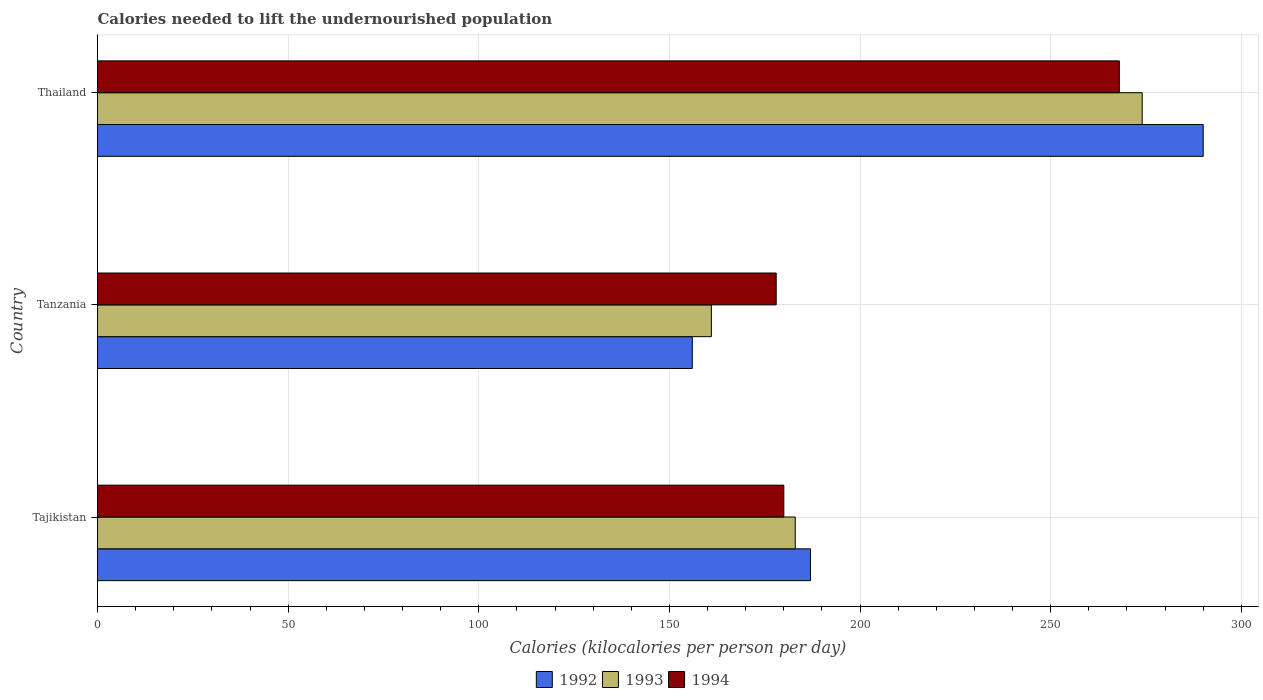How many groups of bars are there?
Provide a short and direct response. 3. Are the number of bars per tick equal to the number of legend labels?
Your response must be concise. Yes. Are the number of bars on each tick of the Y-axis equal?
Your answer should be very brief. Yes. How many bars are there on the 2nd tick from the bottom?
Keep it short and to the point. 3. What is the label of the 2nd group of bars from the top?
Make the answer very short. Tanzania. What is the total calories needed to lift the undernourished population in 1994 in Tajikistan?
Give a very brief answer. 180. Across all countries, what is the maximum total calories needed to lift the undernourished population in 1992?
Offer a very short reply. 290. Across all countries, what is the minimum total calories needed to lift the undernourished population in 1994?
Make the answer very short. 178. In which country was the total calories needed to lift the undernourished population in 1992 maximum?
Keep it short and to the point. Thailand. In which country was the total calories needed to lift the undernourished population in 1994 minimum?
Ensure brevity in your answer.  Tanzania. What is the total total calories needed to lift the undernourished population in 1993 in the graph?
Your answer should be compact. 618. What is the difference between the total calories needed to lift the undernourished population in 1994 in Tajikistan and that in Tanzania?
Your response must be concise. 2. What is the difference between the total calories needed to lift the undernourished population in 1992 in Thailand and the total calories needed to lift the undernourished population in 1994 in Tajikistan?
Keep it short and to the point. 110. What is the average total calories needed to lift the undernourished population in 1994 per country?
Provide a short and direct response. 208.67. What is the difference between the total calories needed to lift the undernourished population in 1992 and total calories needed to lift the undernourished population in 1994 in Thailand?
Your answer should be compact. 22. What is the ratio of the total calories needed to lift the undernourished population in 1992 in Tanzania to that in Thailand?
Your answer should be very brief. 0.54. Is the total calories needed to lift the undernourished population in 1994 in Tanzania less than that in Thailand?
Provide a succinct answer. Yes. What is the difference between the highest and the lowest total calories needed to lift the undernourished population in 1994?
Give a very brief answer. 90. In how many countries, is the total calories needed to lift the undernourished population in 1993 greater than the average total calories needed to lift the undernourished population in 1993 taken over all countries?
Offer a terse response. 1. What does the 3rd bar from the top in Thailand represents?
Your answer should be very brief. 1992. How many bars are there?
Make the answer very short. 9. What is the difference between two consecutive major ticks on the X-axis?
Your answer should be very brief. 50. Does the graph contain grids?
Provide a succinct answer. Yes. Where does the legend appear in the graph?
Make the answer very short. Bottom center. How many legend labels are there?
Ensure brevity in your answer.  3. What is the title of the graph?
Ensure brevity in your answer.  Calories needed to lift the undernourished population. Does "2010" appear as one of the legend labels in the graph?
Keep it short and to the point. No. What is the label or title of the X-axis?
Provide a succinct answer. Calories (kilocalories per person per day). What is the label or title of the Y-axis?
Ensure brevity in your answer.  Country. What is the Calories (kilocalories per person per day) of 1992 in Tajikistan?
Offer a very short reply. 187. What is the Calories (kilocalories per person per day) in 1993 in Tajikistan?
Provide a succinct answer. 183. What is the Calories (kilocalories per person per day) in 1994 in Tajikistan?
Your answer should be very brief. 180. What is the Calories (kilocalories per person per day) of 1992 in Tanzania?
Provide a short and direct response. 156. What is the Calories (kilocalories per person per day) in 1993 in Tanzania?
Give a very brief answer. 161. What is the Calories (kilocalories per person per day) of 1994 in Tanzania?
Offer a very short reply. 178. What is the Calories (kilocalories per person per day) in 1992 in Thailand?
Your answer should be very brief. 290. What is the Calories (kilocalories per person per day) in 1993 in Thailand?
Provide a succinct answer. 274. What is the Calories (kilocalories per person per day) of 1994 in Thailand?
Offer a very short reply. 268. Across all countries, what is the maximum Calories (kilocalories per person per day) in 1992?
Keep it short and to the point. 290. Across all countries, what is the maximum Calories (kilocalories per person per day) of 1993?
Give a very brief answer. 274. Across all countries, what is the maximum Calories (kilocalories per person per day) in 1994?
Provide a succinct answer. 268. Across all countries, what is the minimum Calories (kilocalories per person per day) of 1992?
Make the answer very short. 156. Across all countries, what is the minimum Calories (kilocalories per person per day) of 1993?
Ensure brevity in your answer.  161. Across all countries, what is the minimum Calories (kilocalories per person per day) in 1994?
Your answer should be very brief. 178. What is the total Calories (kilocalories per person per day) of 1992 in the graph?
Keep it short and to the point. 633. What is the total Calories (kilocalories per person per day) in 1993 in the graph?
Provide a succinct answer. 618. What is the total Calories (kilocalories per person per day) of 1994 in the graph?
Ensure brevity in your answer.  626. What is the difference between the Calories (kilocalories per person per day) in 1992 in Tajikistan and that in Tanzania?
Your response must be concise. 31. What is the difference between the Calories (kilocalories per person per day) of 1993 in Tajikistan and that in Tanzania?
Keep it short and to the point. 22. What is the difference between the Calories (kilocalories per person per day) of 1994 in Tajikistan and that in Tanzania?
Provide a short and direct response. 2. What is the difference between the Calories (kilocalories per person per day) of 1992 in Tajikistan and that in Thailand?
Your response must be concise. -103. What is the difference between the Calories (kilocalories per person per day) in 1993 in Tajikistan and that in Thailand?
Your answer should be compact. -91. What is the difference between the Calories (kilocalories per person per day) of 1994 in Tajikistan and that in Thailand?
Ensure brevity in your answer.  -88. What is the difference between the Calories (kilocalories per person per day) of 1992 in Tanzania and that in Thailand?
Ensure brevity in your answer.  -134. What is the difference between the Calories (kilocalories per person per day) in 1993 in Tanzania and that in Thailand?
Give a very brief answer. -113. What is the difference between the Calories (kilocalories per person per day) in 1994 in Tanzania and that in Thailand?
Provide a short and direct response. -90. What is the difference between the Calories (kilocalories per person per day) of 1992 in Tajikistan and the Calories (kilocalories per person per day) of 1993 in Tanzania?
Your response must be concise. 26. What is the difference between the Calories (kilocalories per person per day) in 1993 in Tajikistan and the Calories (kilocalories per person per day) in 1994 in Tanzania?
Provide a short and direct response. 5. What is the difference between the Calories (kilocalories per person per day) of 1992 in Tajikistan and the Calories (kilocalories per person per day) of 1993 in Thailand?
Offer a very short reply. -87. What is the difference between the Calories (kilocalories per person per day) of 1992 in Tajikistan and the Calories (kilocalories per person per day) of 1994 in Thailand?
Offer a terse response. -81. What is the difference between the Calories (kilocalories per person per day) of 1993 in Tajikistan and the Calories (kilocalories per person per day) of 1994 in Thailand?
Your answer should be very brief. -85. What is the difference between the Calories (kilocalories per person per day) of 1992 in Tanzania and the Calories (kilocalories per person per day) of 1993 in Thailand?
Offer a very short reply. -118. What is the difference between the Calories (kilocalories per person per day) in 1992 in Tanzania and the Calories (kilocalories per person per day) in 1994 in Thailand?
Your answer should be very brief. -112. What is the difference between the Calories (kilocalories per person per day) of 1993 in Tanzania and the Calories (kilocalories per person per day) of 1994 in Thailand?
Your response must be concise. -107. What is the average Calories (kilocalories per person per day) of 1992 per country?
Make the answer very short. 211. What is the average Calories (kilocalories per person per day) of 1993 per country?
Your answer should be compact. 206. What is the average Calories (kilocalories per person per day) of 1994 per country?
Your answer should be compact. 208.67. What is the difference between the Calories (kilocalories per person per day) of 1992 and Calories (kilocalories per person per day) of 1993 in Tajikistan?
Offer a very short reply. 4. What is the difference between the Calories (kilocalories per person per day) in 1992 and Calories (kilocalories per person per day) in 1994 in Tajikistan?
Offer a terse response. 7. What is the difference between the Calories (kilocalories per person per day) of 1993 and Calories (kilocalories per person per day) of 1994 in Tajikistan?
Your answer should be very brief. 3. What is the difference between the Calories (kilocalories per person per day) of 1992 and Calories (kilocalories per person per day) of 1994 in Tanzania?
Provide a short and direct response. -22. What is the difference between the Calories (kilocalories per person per day) in 1993 and Calories (kilocalories per person per day) in 1994 in Tanzania?
Ensure brevity in your answer.  -17. What is the difference between the Calories (kilocalories per person per day) in 1993 and Calories (kilocalories per person per day) in 1994 in Thailand?
Offer a very short reply. 6. What is the ratio of the Calories (kilocalories per person per day) in 1992 in Tajikistan to that in Tanzania?
Give a very brief answer. 1.2. What is the ratio of the Calories (kilocalories per person per day) of 1993 in Tajikistan to that in Tanzania?
Offer a terse response. 1.14. What is the ratio of the Calories (kilocalories per person per day) in 1994 in Tajikistan to that in Tanzania?
Your response must be concise. 1.01. What is the ratio of the Calories (kilocalories per person per day) of 1992 in Tajikistan to that in Thailand?
Provide a short and direct response. 0.64. What is the ratio of the Calories (kilocalories per person per day) of 1993 in Tajikistan to that in Thailand?
Your response must be concise. 0.67. What is the ratio of the Calories (kilocalories per person per day) of 1994 in Tajikistan to that in Thailand?
Provide a short and direct response. 0.67. What is the ratio of the Calories (kilocalories per person per day) in 1992 in Tanzania to that in Thailand?
Provide a short and direct response. 0.54. What is the ratio of the Calories (kilocalories per person per day) in 1993 in Tanzania to that in Thailand?
Offer a very short reply. 0.59. What is the ratio of the Calories (kilocalories per person per day) of 1994 in Tanzania to that in Thailand?
Make the answer very short. 0.66. What is the difference between the highest and the second highest Calories (kilocalories per person per day) of 1992?
Make the answer very short. 103. What is the difference between the highest and the second highest Calories (kilocalories per person per day) in 1993?
Offer a terse response. 91. What is the difference between the highest and the lowest Calories (kilocalories per person per day) in 1992?
Your response must be concise. 134. What is the difference between the highest and the lowest Calories (kilocalories per person per day) of 1993?
Ensure brevity in your answer.  113. What is the difference between the highest and the lowest Calories (kilocalories per person per day) of 1994?
Your answer should be very brief. 90. 